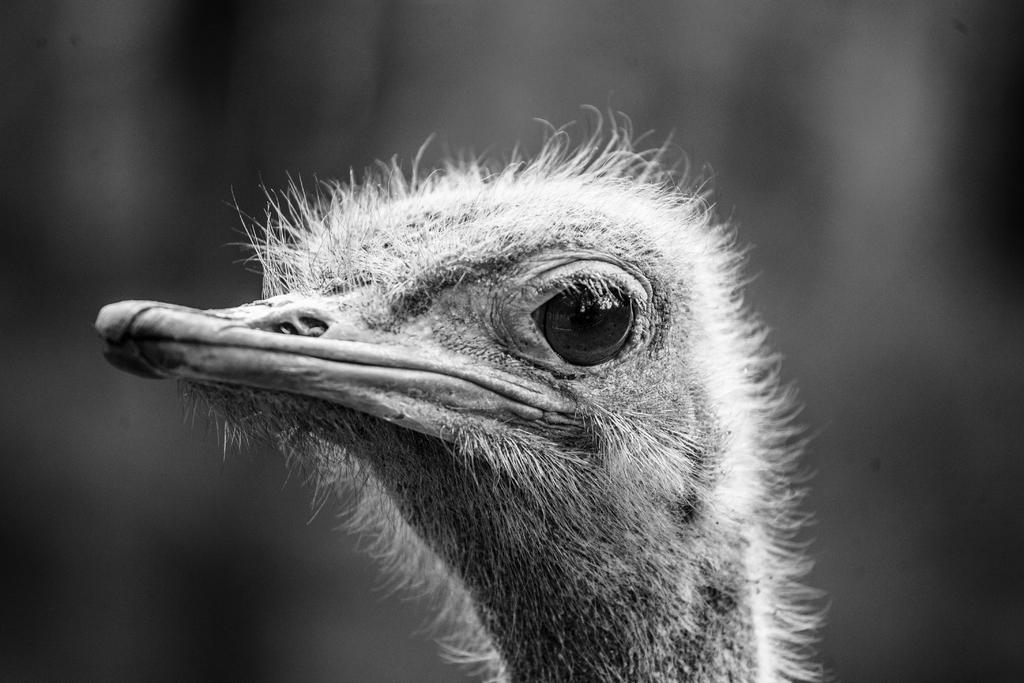What type of animal is in the image? There is a bird in the image. Can you describe the bird's eye? The bird has a large eye. What is the shape of the bird's beak? The bird has a long beak. What color scheme is used in the image? The image is black and white in color. Where is the cemetery located in the image? There is no cemetery present in the image; it features a bird with a large eye and a long beak. 